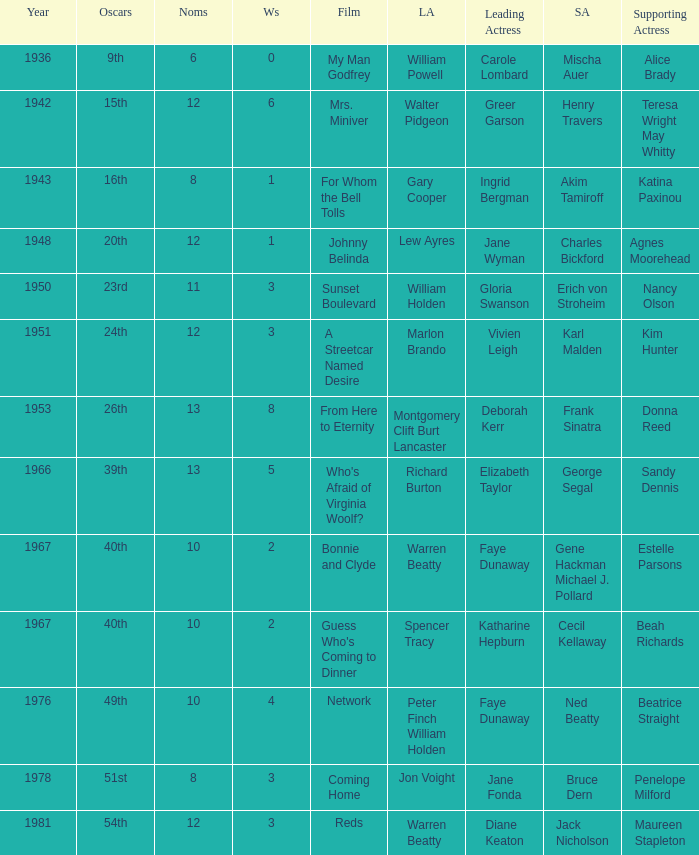Who was the supporting actress in "For Whom the Bell Tolls"? Katina Paxinou. Help me parse the entirety of this table. {'header': ['Year', 'Oscars', 'Noms', 'Ws', 'Film', 'LA', 'Leading Actress', 'SA', 'Supporting Actress'], 'rows': [['1936', '9th', '6', '0', 'My Man Godfrey', 'William Powell', 'Carole Lombard', 'Mischa Auer', 'Alice Brady'], ['1942', '15th', '12', '6', 'Mrs. Miniver', 'Walter Pidgeon', 'Greer Garson', 'Henry Travers', 'Teresa Wright May Whitty'], ['1943', '16th', '8', '1', 'For Whom the Bell Tolls', 'Gary Cooper', 'Ingrid Bergman', 'Akim Tamiroff', 'Katina Paxinou'], ['1948', '20th', '12', '1', 'Johnny Belinda', 'Lew Ayres', 'Jane Wyman', 'Charles Bickford', 'Agnes Moorehead'], ['1950', '23rd', '11', '3', 'Sunset Boulevard', 'William Holden', 'Gloria Swanson', 'Erich von Stroheim', 'Nancy Olson'], ['1951', '24th', '12', '3', 'A Streetcar Named Desire', 'Marlon Brando', 'Vivien Leigh', 'Karl Malden', 'Kim Hunter'], ['1953', '26th', '13', '8', 'From Here to Eternity', 'Montgomery Clift Burt Lancaster', 'Deborah Kerr', 'Frank Sinatra', 'Donna Reed'], ['1966', '39th', '13', '5', "Who's Afraid of Virginia Woolf?", 'Richard Burton', 'Elizabeth Taylor', 'George Segal', 'Sandy Dennis'], ['1967', '40th', '10', '2', 'Bonnie and Clyde', 'Warren Beatty', 'Faye Dunaway', 'Gene Hackman Michael J. Pollard', 'Estelle Parsons'], ['1967', '40th', '10', '2', "Guess Who's Coming to Dinner", 'Spencer Tracy', 'Katharine Hepburn', 'Cecil Kellaway', 'Beah Richards'], ['1976', '49th', '10', '4', 'Network', 'Peter Finch William Holden', 'Faye Dunaway', 'Ned Beatty', 'Beatrice Straight'], ['1978', '51st', '8', '3', 'Coming Home', 'Jon Voight', 'Jane Fonda', 'Bruce Dern', 'Penelope Milford'], ['1981', '54th', '12', '3', 'Reds', 'Warren Beatty', 'Diane Keaton', 'Jack Nicholson', 'Maureen Stapleton']]} 